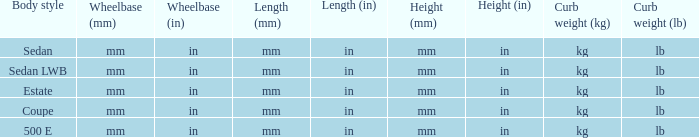What's the length of the model with 500 E body style? Mm (in). Could you parse the entire table as a dict? {'header': ['Body style', 'Wheelbase (mm)', 'Wheelbase (in)', 'Length (mm)', 'Length (in)', 'Height (mm)', 'Height (in)', 'Curb weight (kg)', 'Curb weight (lb)'], 'rows': [['Sedan', 'mm', 'in', 'mm', 'in', 'mm', 'in', 'kg', 'lb'], ['Sedan LWB', 'mm', 'in', 'mm', 'in', 'mm', 'in', 'kg', 'lb'], ['Estate', 'mm', 'in', 'mm', 'in', 'mm', 'in', 'kg', 'lb'], ['Coupe', 'mm', 'in', 'mm', 'in', 'mm', 'in', 'kg', 'lb'], ['500 E', 'mm', 'in', 'mm', 'in', 'mm', 'in', 'kg', 'lb']]} 